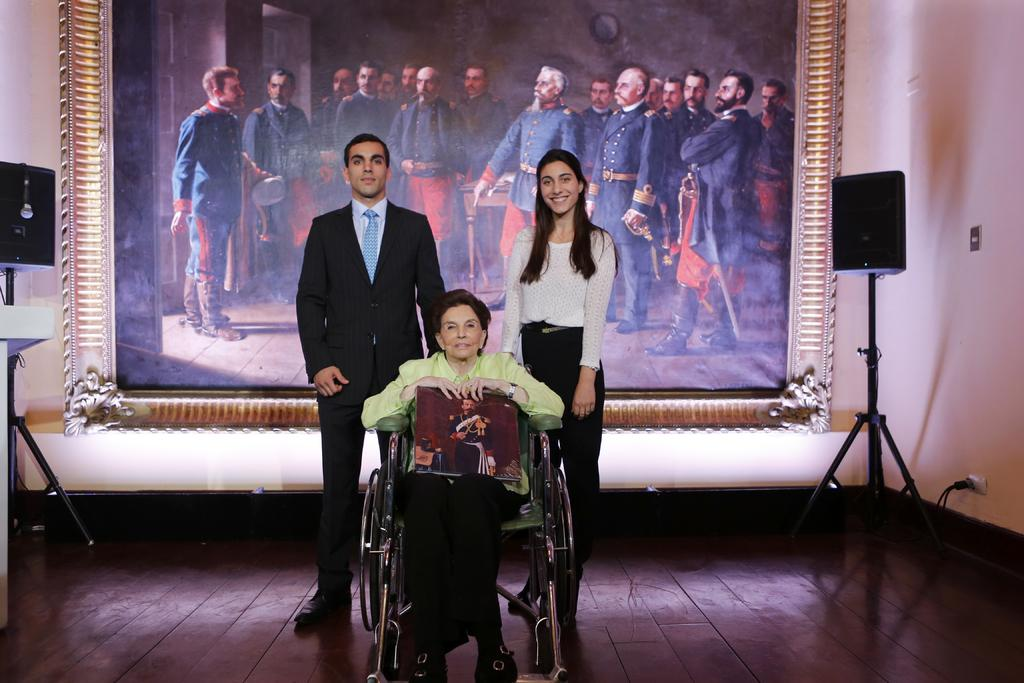How many people are present in the image? There are two people standing and one woman sitting in the image, making a total of three people. What is the woman sitting on in the image? The woman is sitting on a chair in the image. What can be seen near the people in the image? There are speakers visible in the image. What is the woman holding in the image? The woman is holding a book in the image. What is visible in the background of the image? There is a picture of a group of people in the background of the image. What type of clam is being tasted by the dad in the image? There is no dad or clam present in the image; it features two people standing and a woman sitting with a book. 